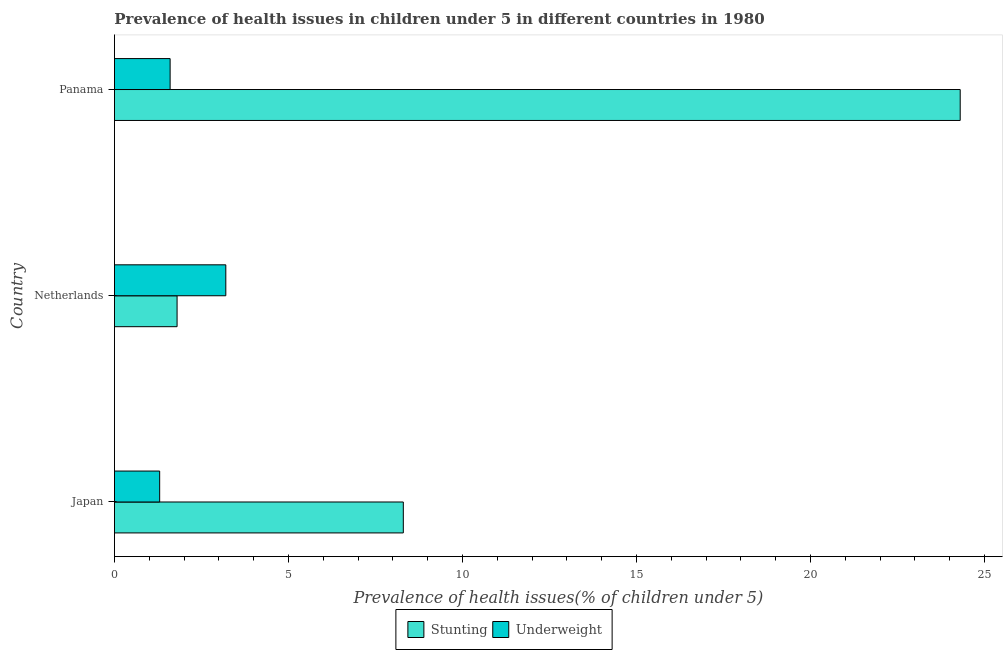How many different coloured bars are there?
Ensure brevity in your answer.  2. Are the number of bars on each tick of the Y-axis equal?
Provide a short and direct response. Yes. How many bars are there on the 1st tick from the top?
Your answer should be compact. 2. What is the percentage of underweight children in Japan?
Provide a succinct answer. 1.3. Across all countries, what is the maximum percentage of stunted children?
Give a very brief answer. 24.3. Across all countries, what is the minimum percentage of stunted children?
Offer a terse response. 1.8. What is the total percentage of stunted children in the graph?
Your answer should be compact. 34.4. What is the difference between the percentage of stunted children in Japan and that in Netherlands?
Make the answer very short. 6.5. What is the difference between the percentage of underweight children in Panama and the percentage of stunted children in Netherlands?
Your answer should be very brief. -0.2. What is the average percentage of underweight children per country?
Keep it short and to the point. 2.03. What is the difference between the percentage of stunted children and percentage of underweight children in Panama?
Your answer should be very brief. 22.7. What is the ratio of the percentage of stunted children in Japan to that in Netherlands?
Offer a terse response. 4.61. Is the percentage of stunted children in Japan less than that in Netherlands?
Give a very brief answer. No. Is the difference between the percentage of stunted children in Japan and Panama greater than the difference between the percentage of underweight children in Japan and Panama?
Make the answer very short. No. What is the difference between the highest and the second highest percentage of underweight children?
Give a very brief answer. 1.6. What does the 1st bar from the top in Japan represents?
Your answer should be very brief. Underweight. What does the 2nd bar from the bottom in Netherlands represents?
Provide a short and direct response. Underweight. How many bars are there?
Make the answer very short. 6. What is the difference between two consecutive major ticks on the X-axis?
Provide a short and direct response. 5. Are the values on the major ticks of X-axis written in scientific E-notation?
Make the answer very short. No. Does the graph contain any zero values?
Provide a succinct answer. No. Does the graph contain grids?
Your response must be concise. No. Where does the legend appear in the graph?
Keep it short and to the point. Bottom center. How are the legend labels stacked?
Provide a succinct answer. Horizontal. What is the title of the graph?
Ensure brevity in your answer.  Prevalence of health issues in children under 5 in different countries in 1980. What is the label or title of the X-axis?
Make the answer very short. Prevalence of health issues(% of children under 5). What is the label or title of the Y-axis?
Keep it short and to the point. Country. What is the Prevalence of health issues(% of children under 5) of Stunting in Japan?
Provide a short and direct response. 8.3. What is the Prevalence of health issues(% of children under 5) of Underweight in Japan?
Provide a short and direct response. 1.3. What is the Prevalence of health issues(% of children under 5) in Stunting in Netherlands?
Make the answer very short. 1.8. What is the Prevalence of health issues(% of children under 5) of Underweight in Netherlands?
Provide a succinct answer. 3.2. What is the Prevalence of health issues(% of children under 5) in Stunting in Panama?
Offer a very short reply. 24.3. What is the Prevalence of health issues(% of children under 5) of Underweight in Panama?
Give a very brief answer. 1.6. Across all countries, what is the maximum Prevalence of health issues(% of children under 5) of Stunting?
Your response must be concise. 24.3. Across all countries, what is the maximum Prevalence of health issues(% of children under 5) in Underweight?
Provide a succinct answer. 3.2. Across all countries, what is the minimum Prevalence of health issues(% of children under 5) in Stunting?
Provide a succinct answer. 1.8. Across all countries, what is the minimum Prevalence of health issues(% of children under 5) in Underweight?
Give a very brief answer. 1.3. What is the total Prevalence of health issues(% of children under 5) of Stunting in the graph?
Your answer should be compact. 34.4. What is the difference between the Prevalence of health issues(% of children under 5) in Stunting in Japan and that in Netherlands?
Give a very brief answer. 6.5. What is the difference between the Prevalence of health issues(% of children under 5) of Underweight in Japan and that in Netherlands?
Provide a succinct answer. -1.9. What is the difference between the Prevalence of health issues(% of children under 5) of Stunting in Japan and that in Panama?
Keep it short and to the point. -16. What is the difference between the Prevalence of health issues(% of children under 5) of Stunting in Netherlands and that in Panama?
Provide a short and direct response. -22.5. What is the difference between the Prevalence of health issues(% of children under 5) in Stunting in Japan and the Prevalence of health issues(% of children under 5) in Underweight in Panama?
Give a very brief answer. 6.7. What is the difference between the Prevalence of health issues(% of children under 5) in Stunting in Netherlands and the Prevalence of health issues(% of children under 5) in Underweight in Panama?
Give a very brief answer. 0.2. What is the average Prevalence of health issues(% of children under 5) in Stunting per country?
Keep it short and to the point. 11.47. What is the average Prevalence of health issues(% of children under 5) of Underweight per country?
Offer a very short reply. 2.03. What is the difference between the Prevalence of health issues(% of children under 5) of Stunting and Prevalence of health issues(% of children under 5) of Underweight in Japan?
Your response must be concise. 7. What is the difference between the Prevalence of health issues(% of children under 5) of Stunting and Prevalence of health issues(% of children under 5) of Underweight in Netherlands?
Make the answer very short. -1.4. What is the difference between the Prevalence of health issues(% of children under 5) in Stunting and Prevalence of health issues(% of children under 5) in Underweight in Panama?
Offer a very short reply. 22.7. What is the ratio of the Prevalence of health issues(% of children under 5) of Stunting in Japan to that in Netherlands?
Offer a terse response. 4.61. What is the ratio of the Prevalence of health issues(% of children under 5) in Underweight in Japan to that in Netherlands?
Offer a very short reply. 0.41. What is the ratio of the Prevalence of health issues(% of children under 5) in Stunting in Japan to that in Panama?
Make the answer very short. 0.34. What is the ratio of the Prevalence of health issues(% of children under 5) of Underweight in Japan to that in Panama?
Your answer should be very brief. 0.81. What is the ratio of the Prevalence of health issues(% of children under 5) of Stunting in Netherlands to that in Panama?
Your answer should be compact. 0.07. What is the difference between the highest and the second highest Prevalence of health issues(% of children under 5) in Stunting?
Your answer should be compact. 16. What is the difference between the highest and the second highest Prevalence of health issues(% of children under 5) of Underweight?
Provide a short and direct response. 1.6. What is the difference between the highest and the lowest Prevalence of health issues(% of children under 5) of Underweight?
Make the answer very short. 1.9. 